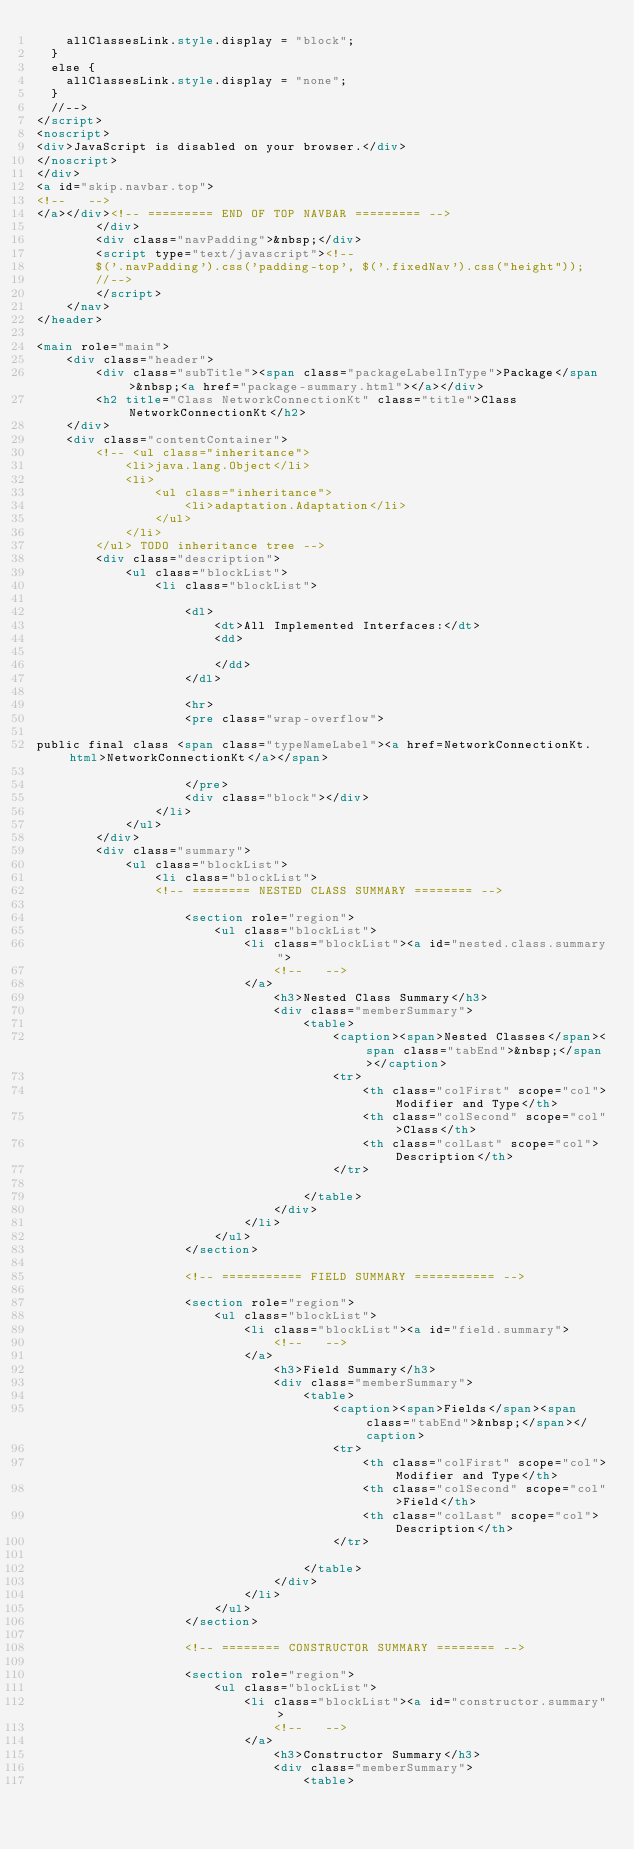Convert code to text. <code><loc_0><loc_0><loc_500><loc_500><_HTML_>    allClassesLink.style.display = "block";
  }
  else {
    allClassesLink.style.display = "none";
  }
  //-->
</script>
<noscript>
<div>JavaScript is disabled on your browser.</div>
</noscript>
</div>
<a id="skip.navbar.top">
<!--   -->
</a></div><!-- ========= END OF TOP NAVBAR ========= -->
        </div>
        <div class="navPadding">&nbsp;</div>
        <script type="text/javascript"><!--
        $('.navPadding').css('padding-top', $('.fixedNav').css("height"));
        //-->
        </script>
    </nav>
</header>

<main role="main">
    <div class="header">
        <div class="subTitle"><span class="packageLabelInType">Package</span>&nbsp;<a href="package-summary.html"></a></div>
        <h2 title="Class NetworkConnectionKt" class="title">Class NetworkConnectionKt</h2>
    </div>
    <div class="contentContainer">
        <!-- <ul class="inheritance">
            <li>java.lang.Object</li>
            <li>
                <ul class="inheritance">
                    <li>adaptation.Adaptation</li>
                </ul>
            </li>
        </ul> TODO inheritance tree -->
        <div class="description">
            <ul class="blockList">
                <li class="blockList">
                    
                    <dl>
                        <dt>All Implemented Interfaces:</dt>
                        <dd>
                            
                        </dd>
                    </dl>
                    
                    <hr>
                    <pre class="wrap-overflow">

public final class <span class="typeNameLabel"><a href=NetworkConnectionKt.html>NetworkConnectionKt</a></span>

                    </pre>
                    <div class="block"></div>
                </li>
            </ul>
        </div>
        <div class="summary">
            <ul class="blockList">
                <li class="blockList">
                <!-- ======== NESTED CLASS SUMMARY ======== -->
                    
                    <section role="region">
                        <ul class="blockList">
                            <li class="blockList"><a id="nested.class.summary">
                                <!--   -->
                            </a>
                                <h3>Nested Class Summary</h3>
                                <div class="memberSummary">
                                    <table>
                                        <caption><span>Nested Classes</span><span class="tabEnd">&nbsp;</span></caption>
                                        <tr>
                                            <th class="colFirst" scope="col">Modifier and Type</th>
                                            <th class="colSecond" scope="col">Class</th>
                                            <th class="colLast" scope="col">Description</th>
                                        </tr>
                                        
                                    </table>
                                </div>
                            </li>
                        </ul>
                    </section>
                    
                    <!-- =========== FIELD SUMMARY =========== -->
                    
                    <section role="region">
                        <ul class="blockList">
                            <li class="blockList"><a id="field.summary">
                                <!--   -->
                            </a>
                                <h3>Field Summary</h3>
                                <div class="memberSummary">
                                    <table>
                                        <caption><span>Fields</span><span class="tabEnd">&nbsp;</span></caption>
                                        <tr>
                                            <th class="colFirst" scope="col">Modifier and Type</th>
                                            <th class="colSecond" scope="col">Field</th>
                                            <th class="colLast" scope="col">Description</th>
                                        </tr>
                                        
                                    </table>
                                </div>
                            </li>
                        </ul>
                    </section>
                    
                    <!-- ======== CONSTRUCTOR SUMMARY ======== -->
                    
                    <section role="region">
                        <ul class="blockList">
                            <li class="blockList"><a id="constructor.summary">
                                <!--   -->
                            </a>
                                <h3>Constructor Summary</h3>
                                <div class="memberSummary">
                                    <table></code> 